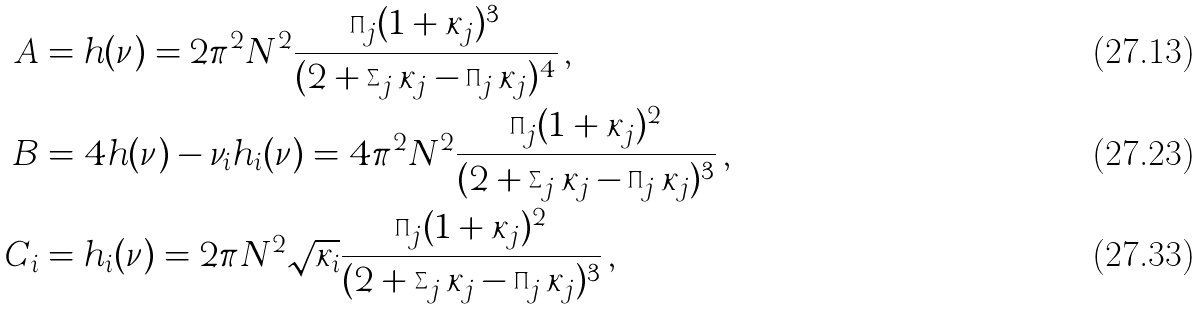<formula> <loc_0><loc_0><loc_500><loc_500>A & = h ( \nu ) = 2 \pi ^ { 2 } N ^ { 2 } \frac { \prod _ { j } ( 1 + \kappa _ { j } ) ^ { 3 } } { ( 2 + \sum _ { j } \kappa _ { j } - \prod _ { j } \kappa _ { j } ) ^ { 4 } } \, , \\ B & = 4 h ( \nu ) - \nu _ { i } h _ { i } ( \nu ) = 4 \pi ^ { 2 } N ^ { 2 } \frac { \prod _ { j } ( 1 + \kappa _ { j } ) ^ { 2 } } { ( { 2 + \sum _ { j } \kappa _ { j } - \prod _ { j } \kappa _ { j } } ) ^ { 3 } } \, , \\ C _ { i } & = h _ { i } ( \nu ) = 2 \pi N ^ { 2 } \sqrt { \kappa _ { i } } \frac { \prod _ { j } ( 1 + \kappa _ { j } ) ^ { 2 } } { ( { 2 + \sum _ { j } \kappa _ { j } - \prod _ { j } \kappa _ { j } } ) ^ { 3 } } \, ,</formula> 